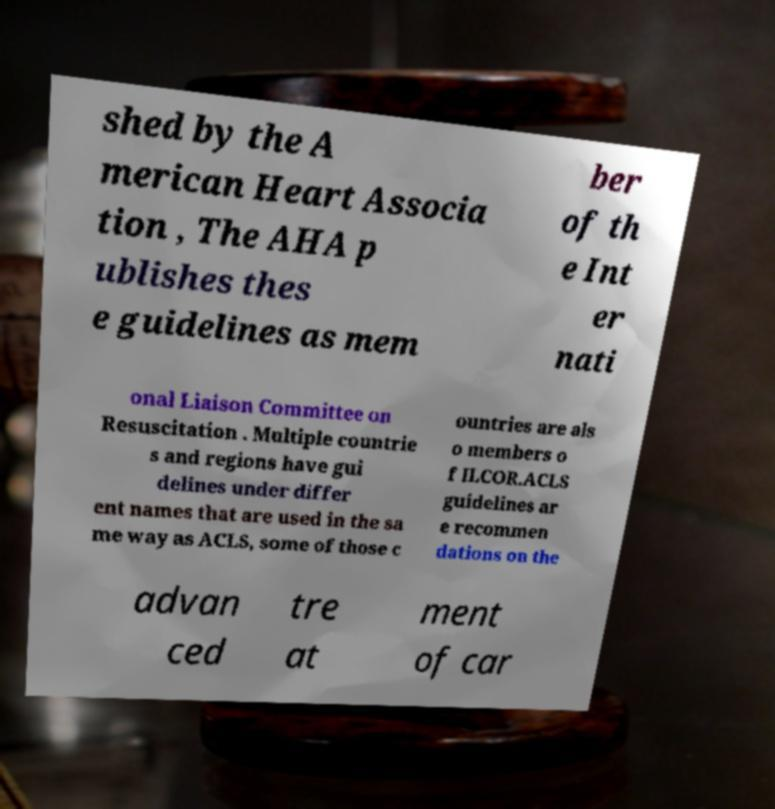Could you extract and type out the text from this image? shed by the A merican Heart Associa tion , The AHA p ublishes thes e guidelines as mem ber of th e Int er nati onal Liaison Committee on Resuscitation . Multiple countrie s and regions have gui delines under differ ent names that are used in the sa me way as ACLS, some of those c ountries are als o members o f ILCOR.ACLS guidelines ar e recommen dations on the advan ced tre at ment of car 